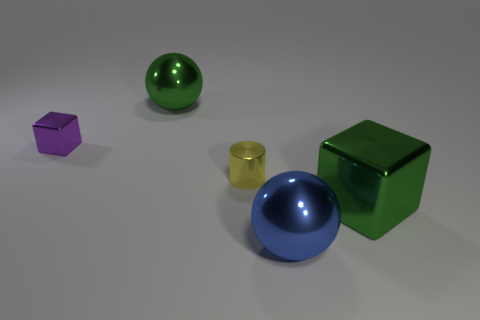What number of spheres are to the right of the big green shiny thing behind the big green metallic object that is in front of the small cube?
Offer a very short reply. 1. How many blue balls are behind the metallic sphere to the left of the small yellow object?
Provide a succinct answer. 0. How many purple objects are in front of the tiny purple metallic thing?
Keep it short and to the point. 0. How many other objects are there of the same size as the blue metal ball?
Provide a short and direct response. 2. The green shiny object behind the small purple metallic cube has what shape?
Provide a short and direct response. Sphere. What is the color of the small thing left of the sphere that is behind the tiny purple block?
Your response must be concise. Purple. How many objects are either blocks to the left of the large green metal ball or small red matte things?
Give a very brief answer. 1. Does the yellow object have the same size as the metallic block left of the large green metallic ball?
Your response must be concise. Yes. How many small things are spheres or blue matte balls?
Provide a short and direct response. 0. What is the shape of the small yellow shiny thing?
Make the answer very short. Cylinder. 